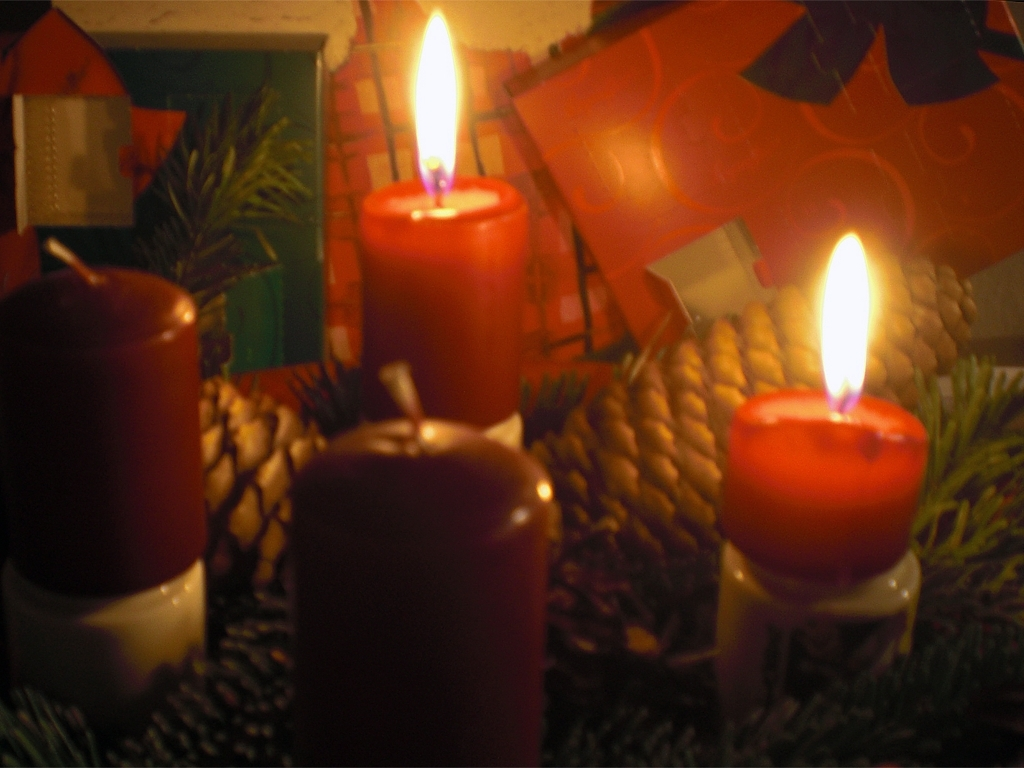What time of year does this scene likely represent? The scene likely represents the winter holiday season, more specifically, Christmas. This is deduced from the presence of pine cones and evergreen branches traditionally associated with Christmas decor, and the visible gift wrap in the backdrop, which is synonymous with gift-giving during the holiday. 